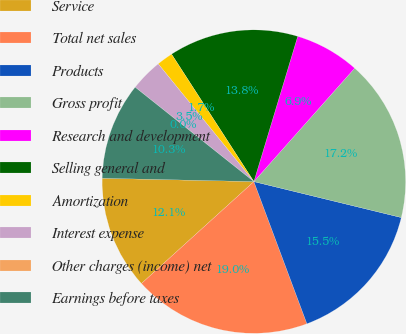Convert chart. <chart><loc_0><loc_0><loc_500><loc_500><pie_chart><fcel>Service<fcel>Total net sales<fcel>Products<fcel>Gross profit<fcel>Research and development<fcel>Selling general and<fcel>Amortization<fcel>Interest expense<fcel>Other charges (income) net<fcel>Earnings before taxes<nl><fcel>12.07%<fcel>18.96%<fcel>15.51%<fcel>17.24%<fcel>6.9%<fcel>13.79%<fcel>1.73%<fcel>3.45%<fcel>0.0%<fcel>10.34%<nl></chart> 